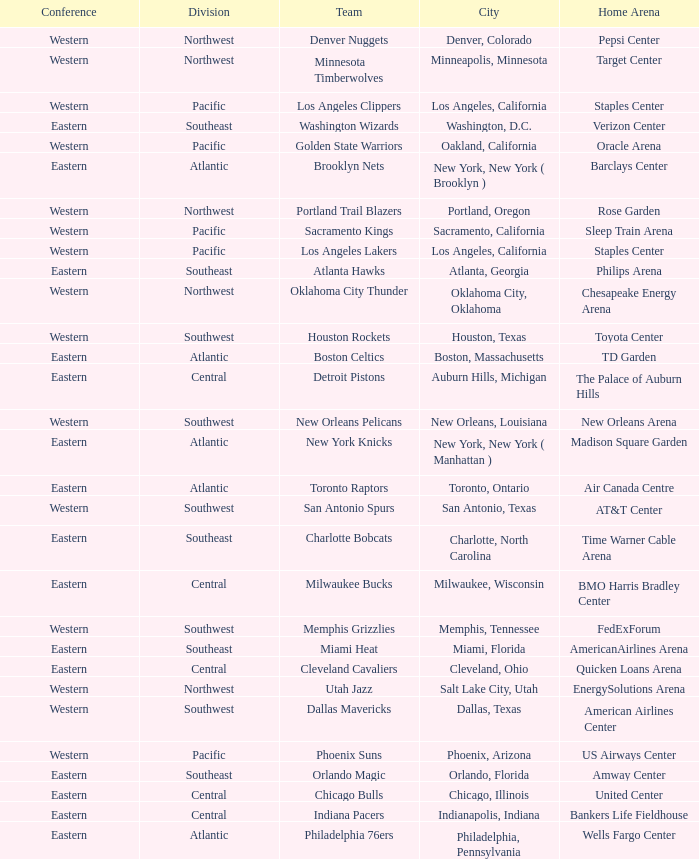Which conference is in Portland, Oregon? Western. 